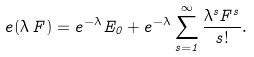<formula> <loc_0><loc_0><loc_500><loc_500>{ e } ( \lambda \, F ) = e ^ { - \lambda } E _ { 0 } + e ^ { - \lambda } \sum _ { s = 1 } ^ { \infty } \frac { \lambda ^ { s } F ^ { s } } { s ! } .</formula> 